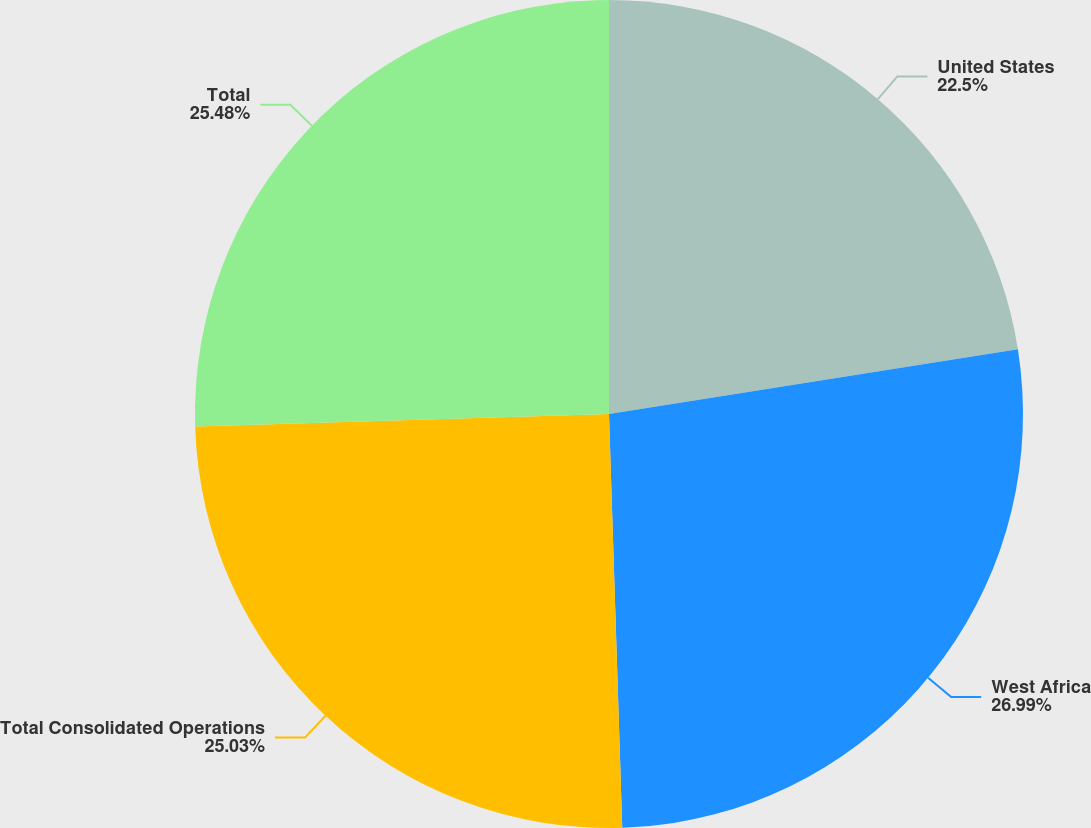Convert chart. <chart><loc_0><loc_0><loc_500><loc_500><pie_chart><fcel>United States<fcel>West Africa<fcel>Total Consolidated Operations<fcel>Total<nl><fcel>22.5%<fcel>26.99%<fcel>25.03%<fcel>25.48%<nl></chart> 